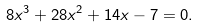<formula> <loc_0><loc_0><loc_500><loc_500>8 x ^ { 3 } + 2 8 x ^ { 2 } + 1 4 x - 7 = 0 .</formula> 